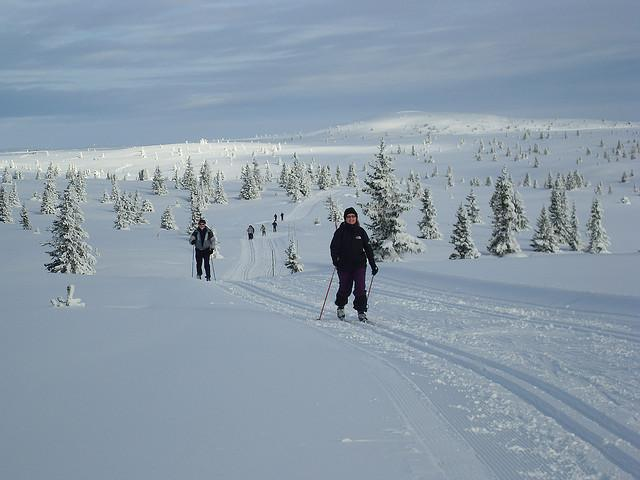What must the weather be like in this area?

Choices:
A) tropical
B) warm
C) mild
D) cold cold 